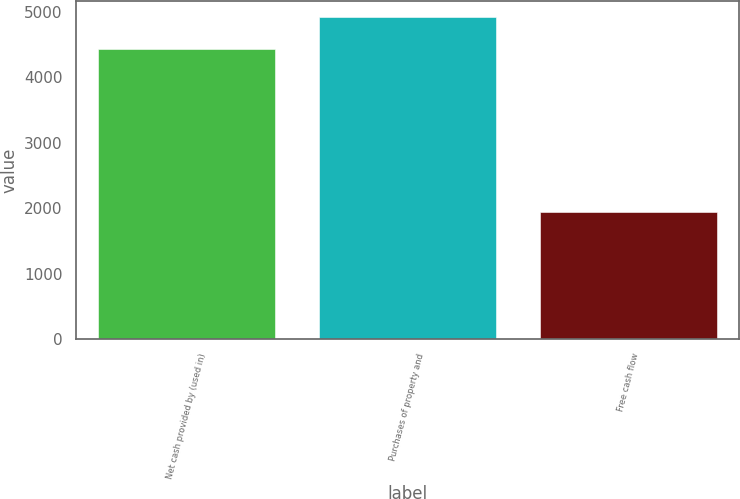Convert chart. <chart><loc_0><loc_0><loc_500><loc_500><bar_chart><fcel>Net cash provided by (used in)<fcel>Purchases of property and<fcel>Free cash flow<nl><fcel>4432<fcel>4921.3<fcel>1949<nl></chart> 